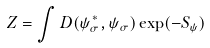Convert formula to latex. <formula><loc_0><loc_0><loc_500><loc_500>Z = \int D ( \psi _ { \sigma } ^ { * } , \psi _ { \sigma } ) \exp ( - S _ { \psi } )</formula> 